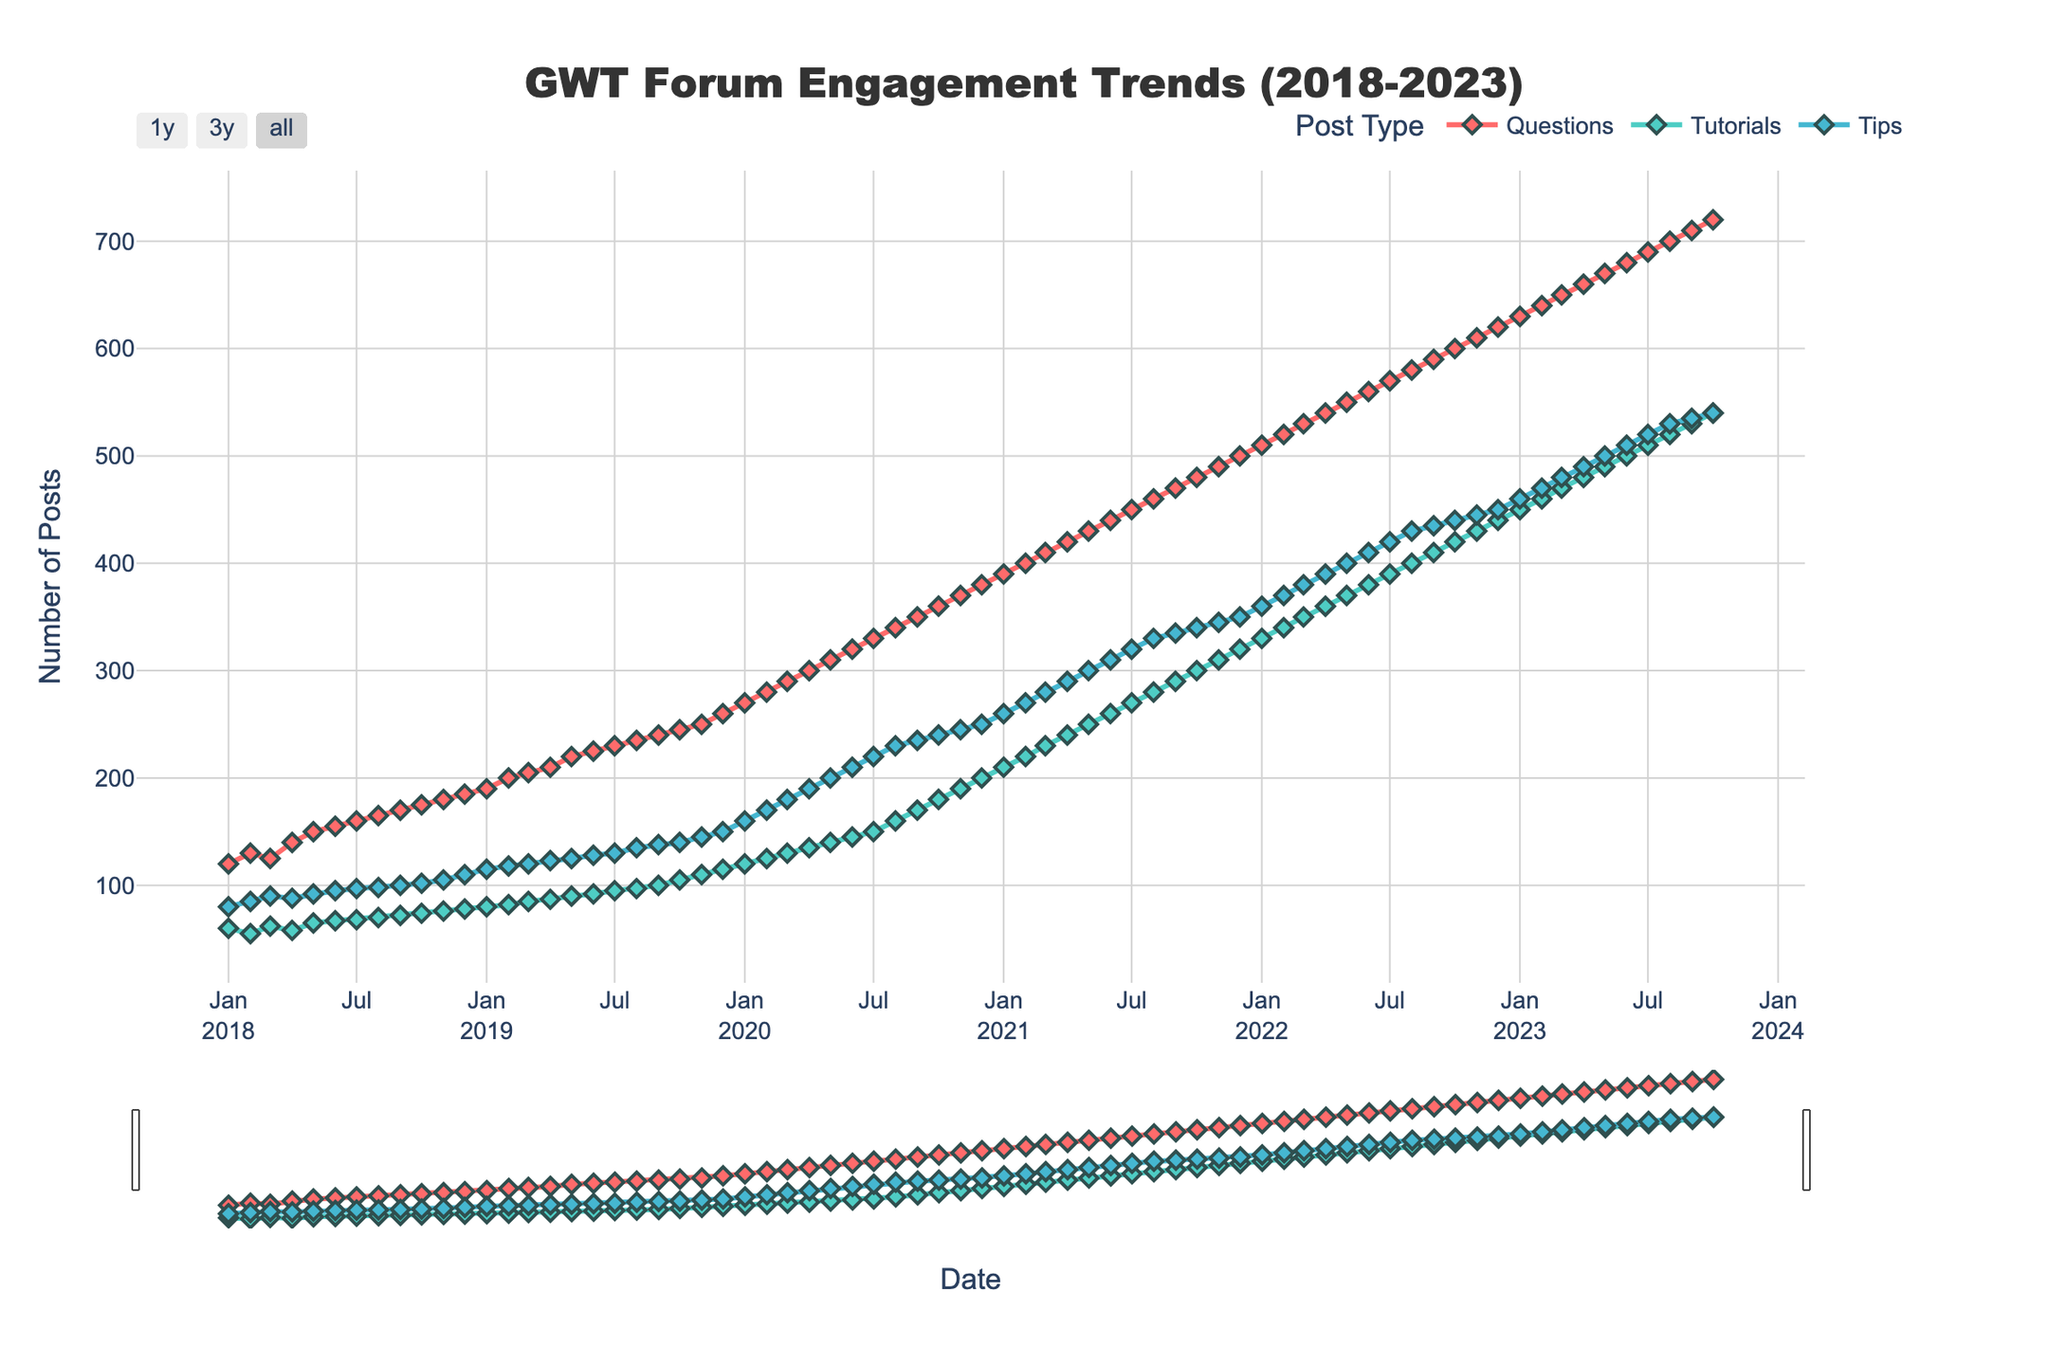what is the title of the figure? The title of the figure is usually located at the top center of the chart. In this case, the title is written in Arial Black font and reads 'GWT Forum Engagement Trends (2018-2023)'.
Answer: GWT Forum Engagement Trends (2018-2023) what are the post types represented by different lines? The figure distinguishes three types of posts using different colored lines: Questions, Tutorials, and Tips identified from the legend.
Answer: Questions, Tutorials, Tips what post type shows the highest number of posts in September 2020? To find the highest number of posts in September 2020, look at the data points for that month across the three post types and compare them. Questions show 350 posts, Tutorials show 170 posts, and Tips show 235 posts. Thus, Questions have the highest number of posts in that month.
Answer: Questions what is the average post count for Tips in 2018? Calculate the average post count for Tips by totaling the monthly data for 2018 and then dividing by 12. The sum for Tips in 2018 is 80+85+90+88+92+95+97+98+100+102+105+110 = 1142, and the average is 1142/12 = 95.17.
Answer: 95.17 how did the number of tutorial posts change from January 2020 to January 2021? Check the values for tutorials in January 2020 and January 2021. In January 2020, there are 120 tutorial posts; in January 2021, there are 210 tutorial posts. The change is 210 - 120 = 90.
Answer: Increased by 90 which month reported an equal number of Tips and Tutorials posts in the year 2023? Compare each month's Tips and Tutorials post counts for 2023 and find when they are equal. In October 2023, both Tips and Tutorials have a count of 540.
Answer: October 2023 what is the overall trend for Questions post count from 2018 to 2023? Analyze the line graph for Questions, identifying trends over time. Observe that the post count for Questions consistently increases from 120 in January 2018 to 720 in October 2023.
Answer: Increasing trend which three months show the highest engagement in Tutorials posts? Identify the three highest data points for Tutorials throughout the entire range. The highest counts occur in October 2023 (540), September 2023 (530), and August 2023 (520).
Answer: October 2023, September 2023, August 2023 did the number of Tips posts ever surpass 250 before 2020? Check Tips post counts from 2018 to the end of 2019 and see if any values exceed 250. The highest value is 150 in December 2019; hence, it never surpassed 250 before 2020.
Answer: No 